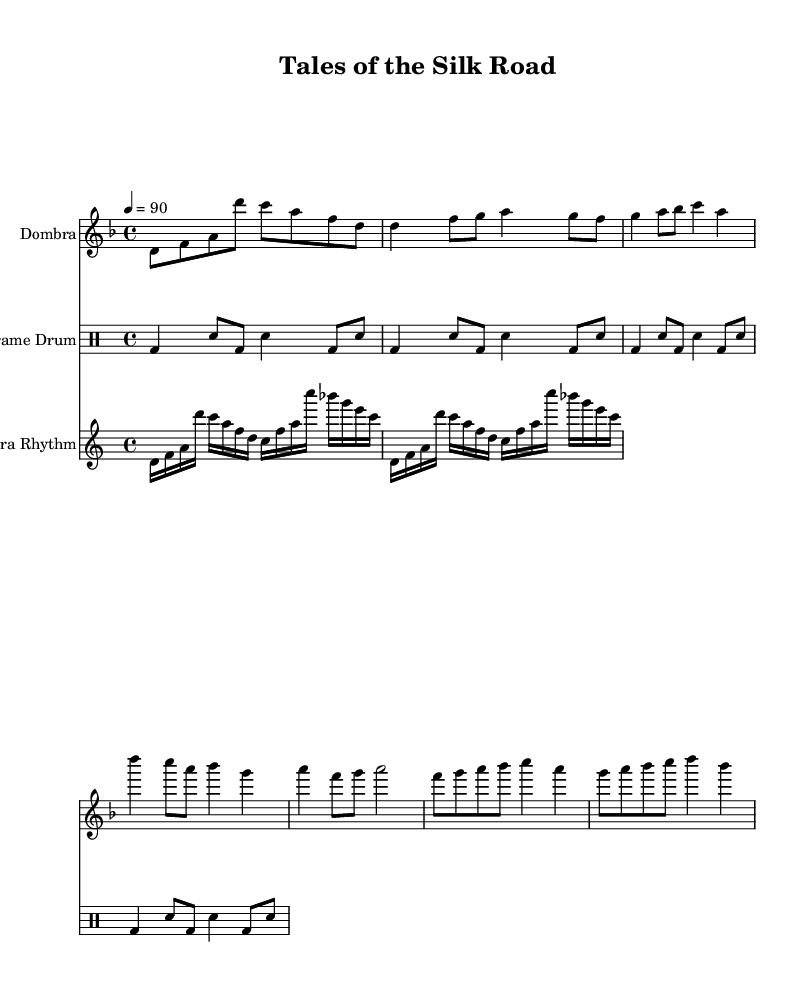What is the key signature of this music? The key signature is identified by looking for sharps or flats at the beginning of the staff. In this case, there are no sharps or flats indicated, thus the key signature corresponds to D minor.
Answer: D minor What is the time signature of this music? The time signature is located at the beginning of the score, expressed as a fraction. Here, it shows 4/4, indicating that there are four beats in a measure and the quarter note gets one beat.
Answer: 4/4 What is the tempo marking for this piece? The tempo marking can be found in the score as a number with a note type. It is indicated as "4 = 90," meaning there should be 90 beats per minute for a quarter note.
Answer: 90 How many parts does the music contain? To find the number of parts, we check for distinct staves in the score. There are three staves: one for the dombra, one for the frame drum, and one for the dombra rhythm. Thus, there are three parts.
Answer: 3 What is the lyric theme of the verse? The lyrics are about stories passed down through time, emphasizing the value of ancient tales. This gives insight into the music's narrative focus.
Answer: Tales of old What is repeated in the drum pattern? To identify the repeated element, we look at the drummode section. The pattern of bass drum and snare drum is repeated multiple times, showing rhythmic continuity.
Answer: bd4 sn8 What narrative style is employed in this rap? The narrative style is characterized by lyrical storytelling, where local legends and folklore are woven into the music, making it a performance of shared cultural history.
Answer: Lyrical storytelling 